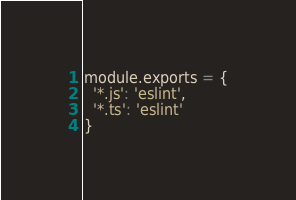Convert code to text. <code><loc_0><loc_0><loc_500><loc_500><_JavaScript_>module.exports = {
  '*.js': 'eslint',
  '*.ts': 'eslint'
}
</code> 